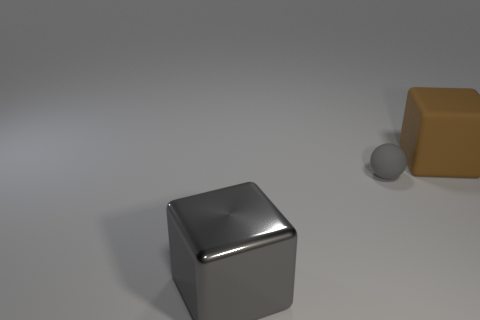The big thing that is in front of the brown block has what shape? The object in front of the brown block is a cube. It has six faces, each in the shape of a square, and every angle is a right angle, which is characteristic of a cube. 